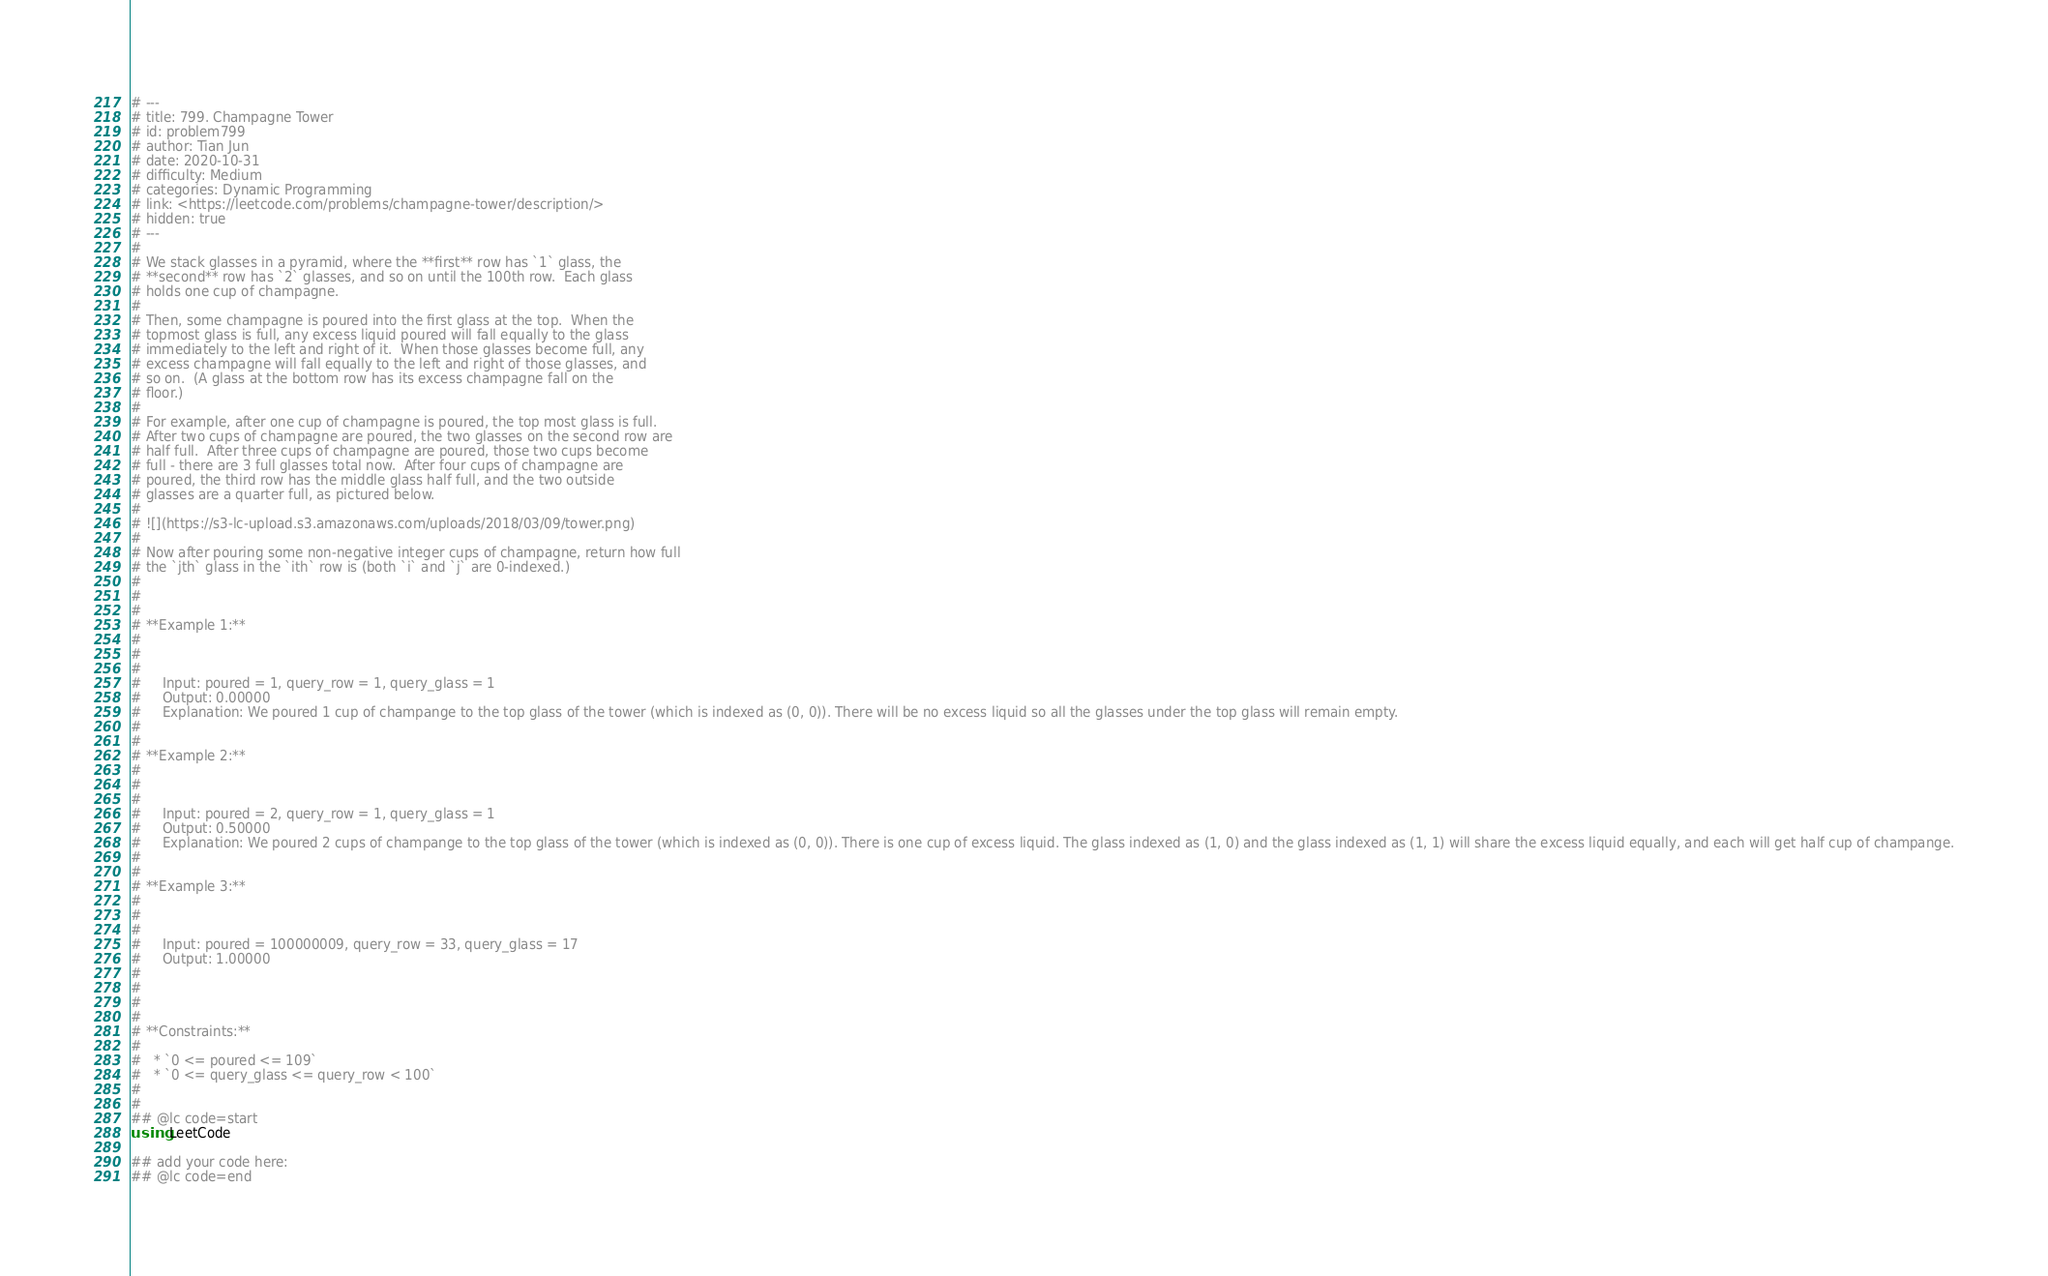<code> <loc_0><loc_0><loc_500><loc_500><_Julia_># ---
# title: 799. Champagne Tower
# id: problem799
# author: Tian Jun
# date: 2020-10-31
# difficulty: Medium
# categories: Dynamic Programming
# link: <https://leetcode.com/problems/champagne-tower/description/>
# hidden: true
# ---
# 
# We stack glasses in a pyramid, where the **first** row has `1` glass, the
# **second** row has `2` glasses, and so on until the 100th row.  Each glass
# holds one cup of champagne.
# 
# Then, some champagne is poured into the first glass at the top.  When the
# topmost glass is full, any excess liquid poured will fall equally to the glass
# immediately to the left and right of it.  When those glasses become full, any
# excess champagne will fall equally to the left and right of those glasses, and
# so on.  (A glass at the bottom row has its excess champagne fall on the
# floor.)
# 
# For example, after one cup of champagne is poured, the top most glass is full.
# After two cups of champagne are poured, the two glasses on the second row are
# half full.  After three cups of champagne are poured, those two cups become
# full - there are 3 full glasses total now.  After four cups of champagne are
# poured, the third row has the middle glass half full, and the two outside
# glasses are a quarter full, as pictured below.
# 
# ![](https://s3-lc-upload.s3.amazonaws.com/uploads/2018/03/09/tower.png)
# 
# Now after pouring some non-negative integer cups of champagne, return how full
# the `jth` glass in the `ith` row is (both `i` and `j` are 0-indexed.)
# 
# 
# 
# **Example 1:**
# 
#     
#     
#     Input: poured = 1, query_row = 1, query_glass = 1
#     Output: 0.00000
#     Explanation: We poured 1 cup of champange to the top glass of the tower (which is indexed as (0, 0)). There will be no excess liquid so all the glasses under the top glass will remain empty.
#     
# 
# **Example 2:**
# 
#     
#     
#     Input: poured = 2, query_row = 1, query_glass = 1
#     Output: 0.50000
#     Explanation: We poured 2 cups of champange to the top glass of the tower (which is indexed as (0, 0)). There is one cup of excess liquid. The glass indexed as (1, 0) and the glass indexed as (1, 1) will share the excess liquid equally, and each will get half cup of champange.
#     
# 
# **Example 3:**
# 
#     
#     
#     Input: poured = 100000009, query_row = 33, query_glass = 17
#     Output: 1.00000
#     
# 
# 
# 
# **Constraints:**
# 
#   * `0 <= poured <= 109`
#   * `0 <= query_glass <= query_row < 100`
# 
# 
## @lc code=start
using LeetCode

## add your code here:
## @lc code=end
</code> 